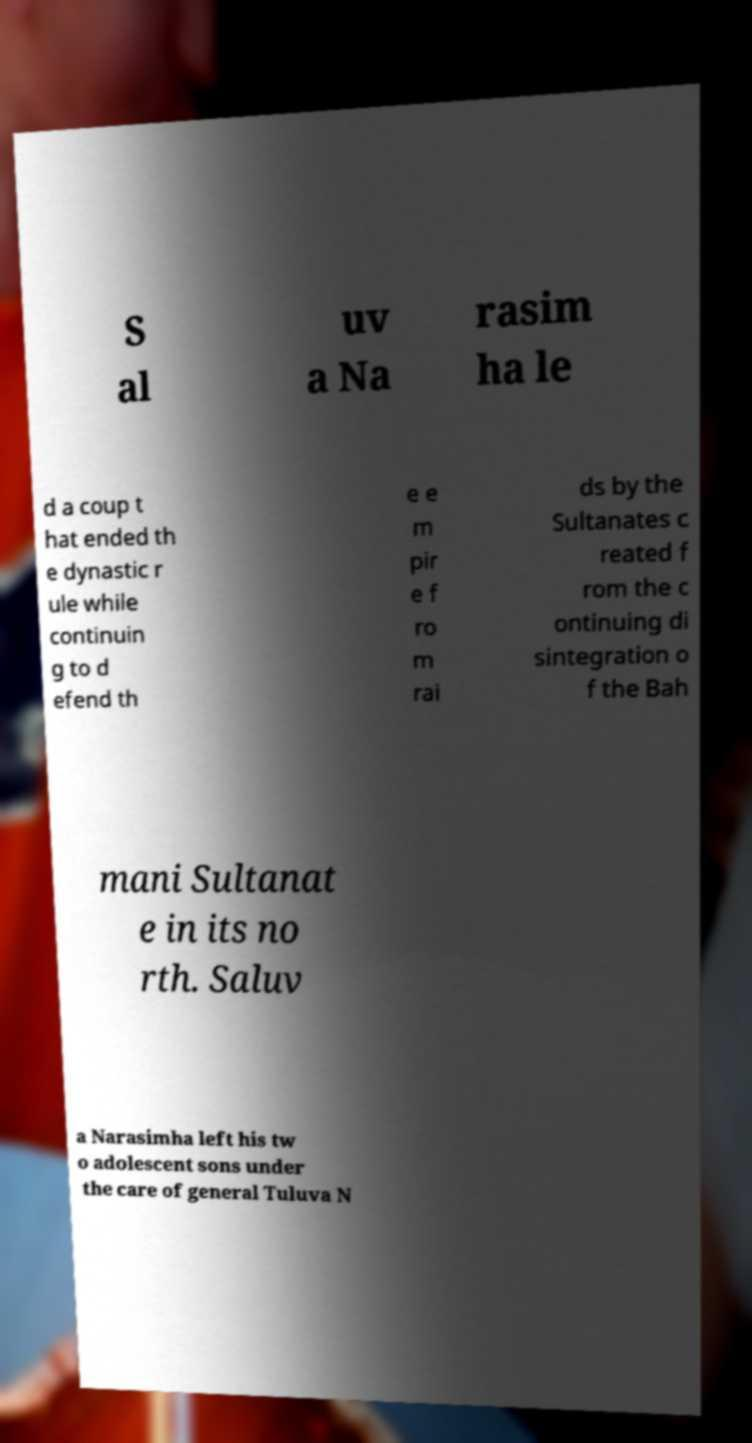Please identify and transcribe the text found in this image. S al uv a Na rasim ha le d a coup t hat ended th e dynastic r ule while continuin g to d efend th e e m pir e f ro m rai ds by the Sultanates c reated f rom the c ontinuing di sintegration o f the Bah mani Sultanat e in its no rth. Saluv a Narasimha left his tw o adolescent sons under the care of general Tuluva N 